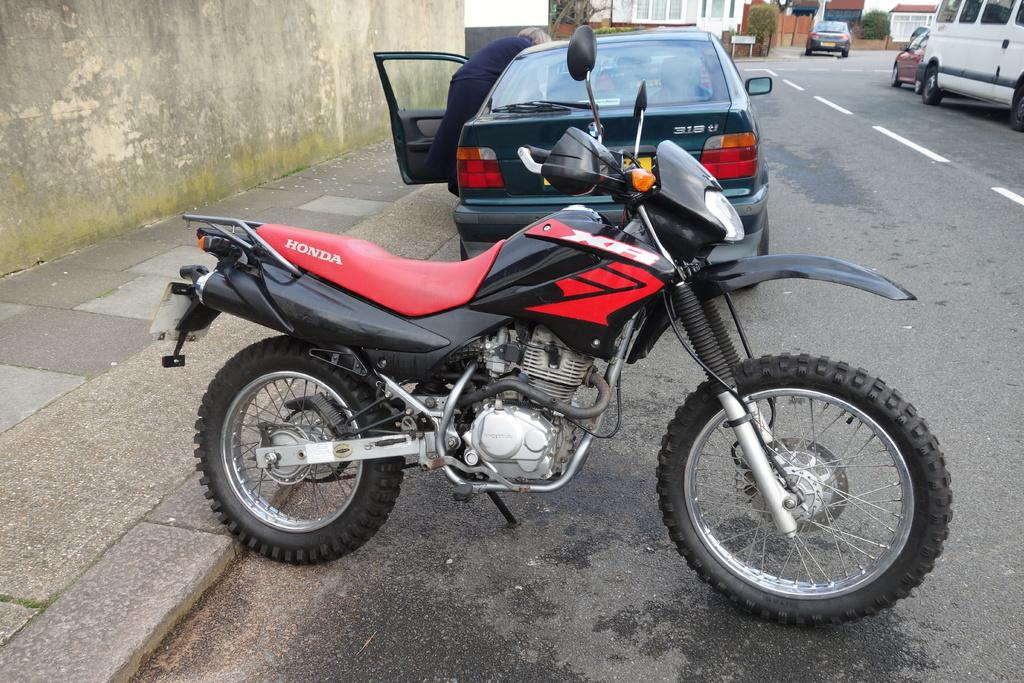What is the main mode of transportation in the image? There is a bike in the image, which is a mode of transportation. Are there any other vehicles besides the bike in the image? Yes, there are other vehicles in the image. What type of structures can be seen in the image? There are buildings in the image. What type of natural elements can be seen in the image? There are trees in the image. Is there a person present in the image? Yes, there is a person in the image. Where is the chicken located in the image? There is no chicken present in the image. What type of station is visible in the image? There is no station present in the image. 